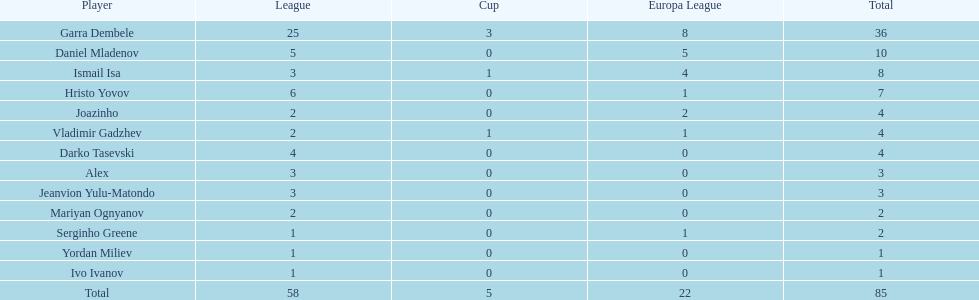Which total is higher, the europa league total or the league total? League. 